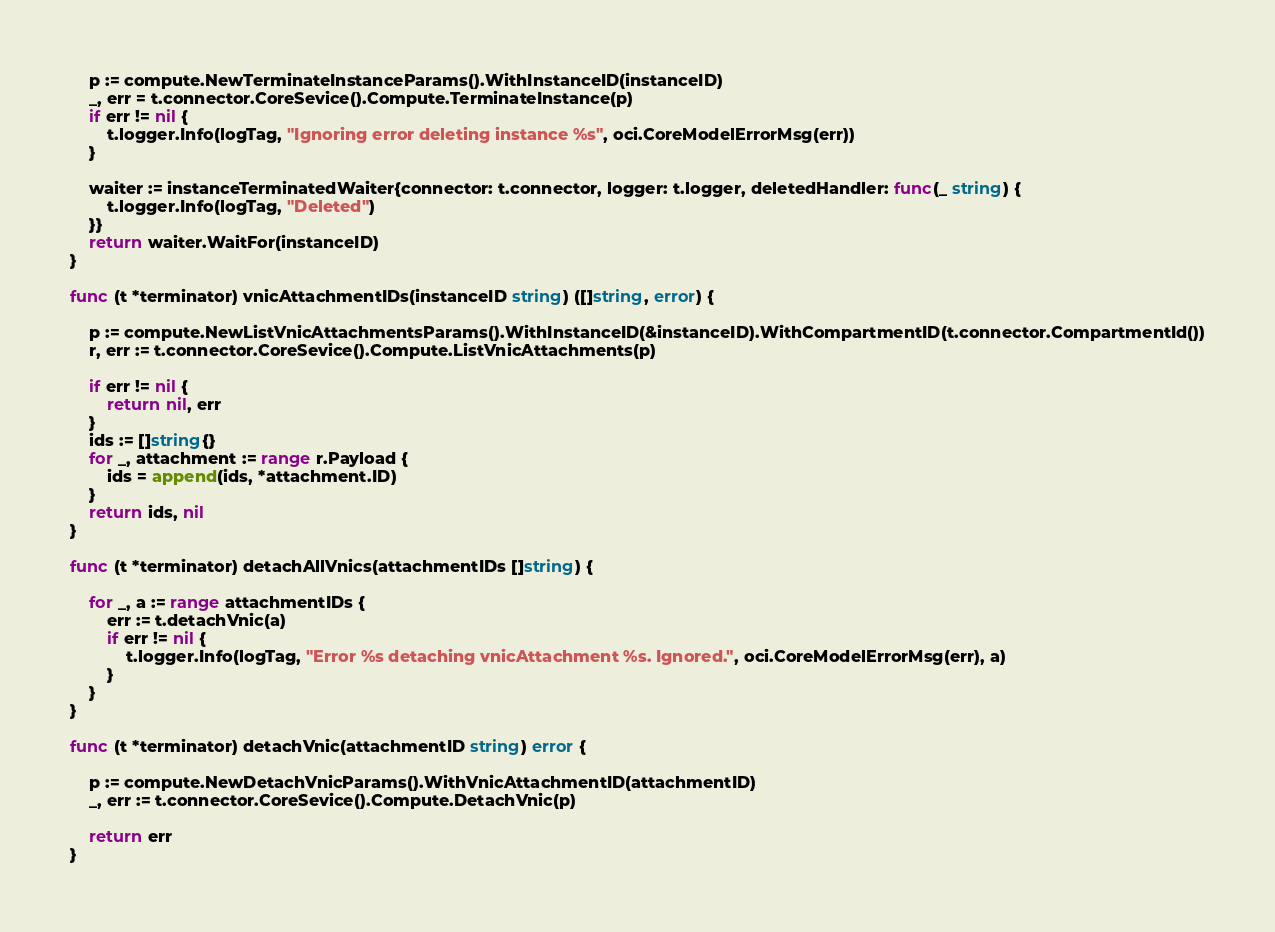<code> <loc_0><loc_0><loc_500><loc_500><_Go_>	p := compute.NewTerminateInstanceParams().WithInstanceID(instanceID)
	_, err = t.connector.CoreSevice().Compute.TerminateInstance(p)
	if err != nil {
		t.logger.Info(logTag, "Ignoring error deleting instance %s", oci.CoreModelErrorMsg(err))
	}

	waiter := instanceTerminatedWaiter{connector: t.connector, logger: t.logger, deletedHandler: func(_ string) {
		t.logger.Info(logTag, "Deleted")
	}}
	return waiter.WaitFor(instanceID)
}

func (t *terminator) vnicAttachmentIDs(instanceID string) ([]string, error) {

	p := compute.NewListVnicAttachmentsParams().WithInstanceID(&instanceID).WithCompartmentID(t.connector.CompartmentId())
	r, err := t.connector.CoreSevice().Compute.ListVnicAttachments(p)

	if err != nil {
		return nil, err
	}
	ids := []string{}
	for _, attachment := range r.Payload {
		ids = append(ids, *attachment.ID)
	}
	return ids, nil
}

func (t *terminator) detachAllVnics(attachmentIDs []string) {

	for _, a := range attachmentIDs {
		err := t.detachVnic(a)
		if err != nil {
			t.logger.Info(logTag, "Error %s detaching vnicAttachment %s. Ignored.", oci.CoreModelErrorMsg(err), a)
		}
	}
}

func (t *terminator) detachVnic(attachmentID string) error {

	p := compute.NewDetachVnicParams().WithVnicAttachmentID(attachmentID)
	_, err := t.connector.CoreSevice().Compute.DetachVnic(p)

	return err
}
</code> 